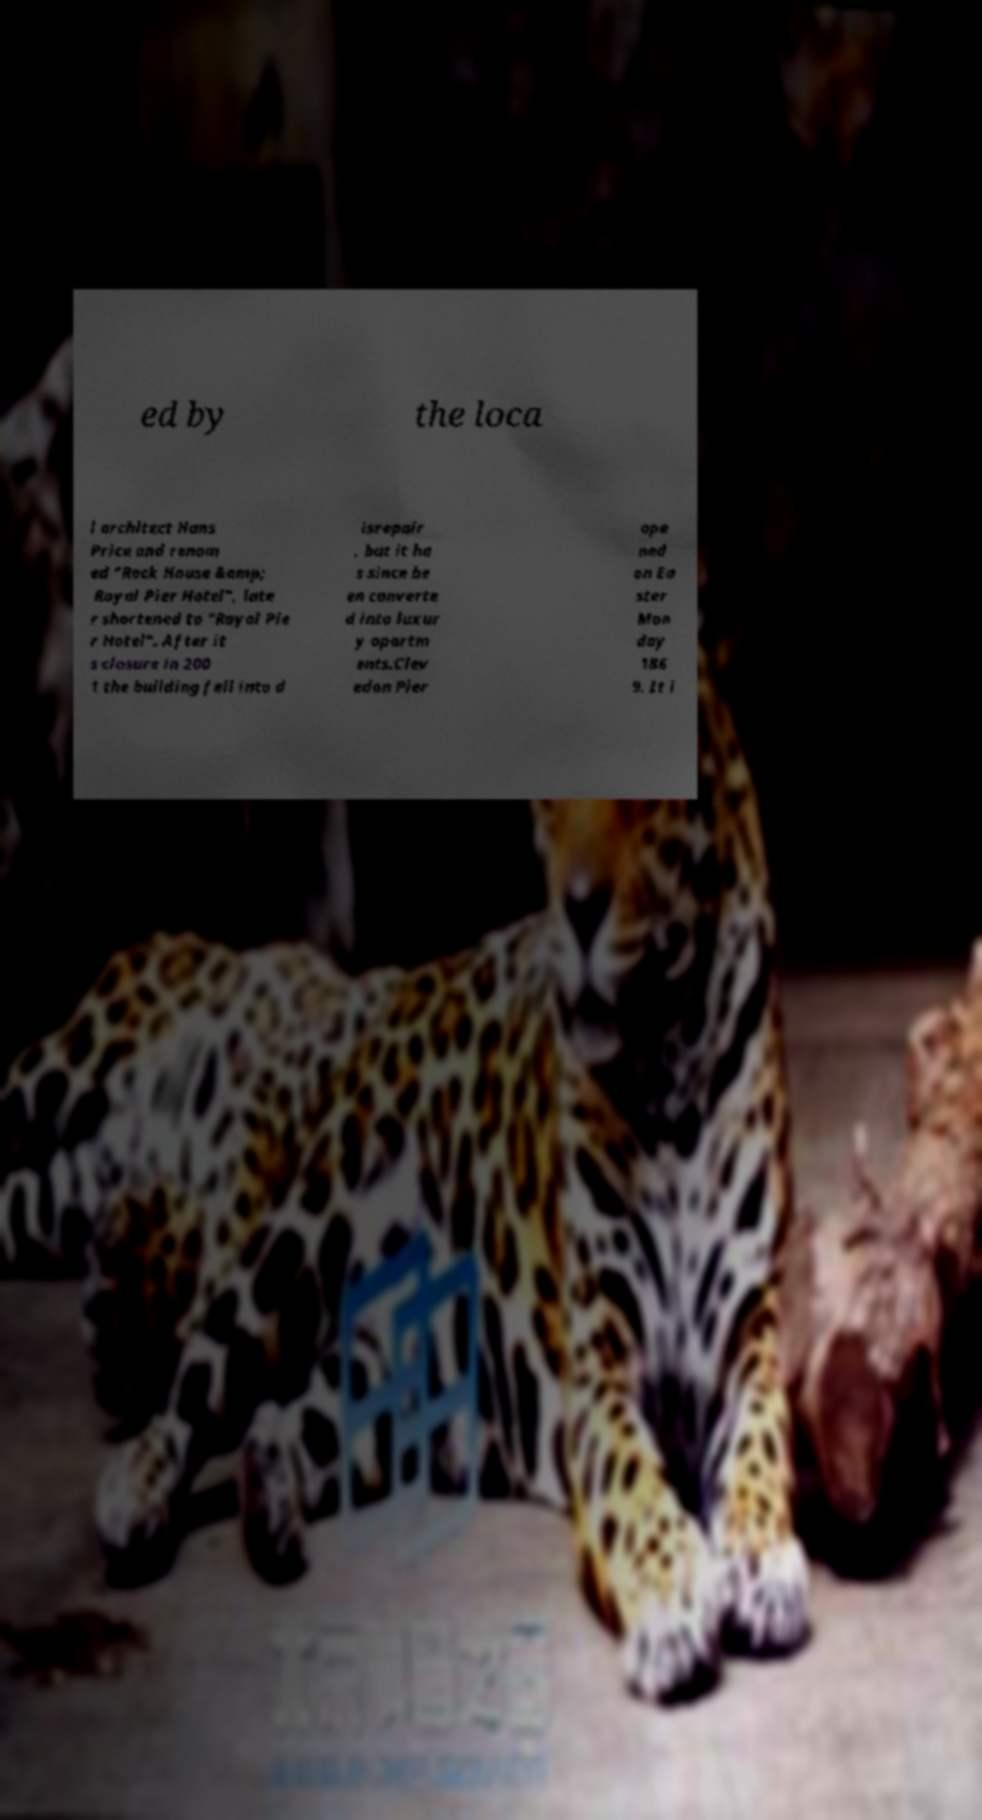Please identify and transcribe the text found in this image. ed by the loca l architect Hans Price and renam ed "Rock House &amp; Royal Pier Hotel", late r shortened to "Royal Pie r Hotel". After it s closure in 200 1 the building fell into d isrepair , but it ha s since be en converte d into luxur y apartm ents.Clev edon Pier ope ned on Ea ster Mon day 186 9. It i 